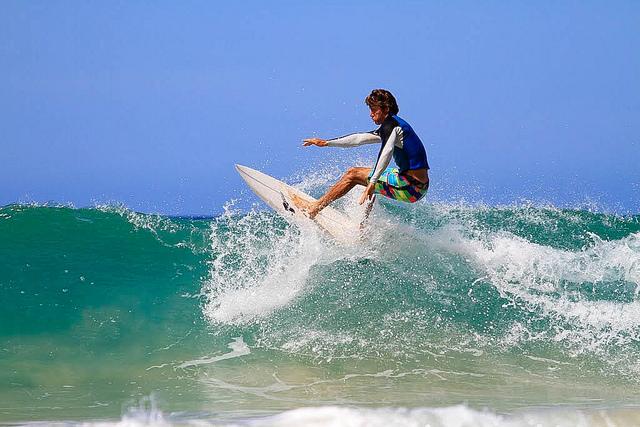Who is the person on the board?
Be succinct. Surfer. Is the sun shining?
Write a very short answer. Yes. What color is the water?
Quick response, please. Blue. 